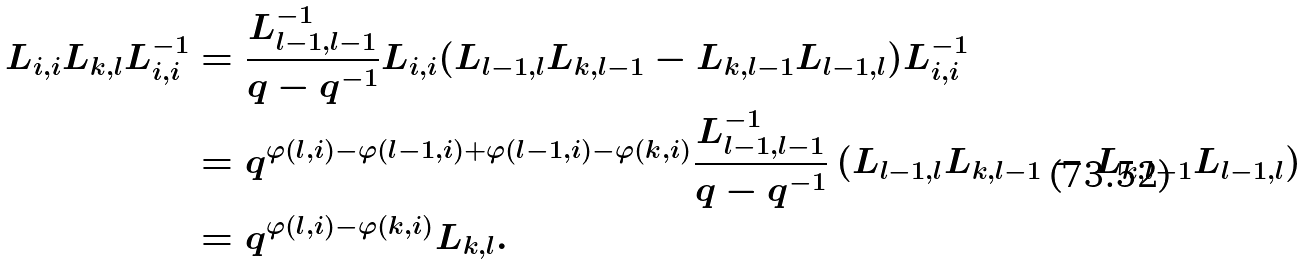<formula> <loc_0><loc_0><loc_500><loc_500>L _ { i , i } L _ { k , l } L _ { i , i } ^ { - 1 } & = \frac { L _ { l - 1 , l - 1 } ^ { - 1 } } { q - q ^ { - 1 } } L _ { i , i } ( L _ { l - 1 , l } L _ { k , l - 1 } - L _ { k , l - 1 } L _ { l - 1 , l } ) L _ { i , i } ^ { - 1 } \\ & = q ^ { \varphi ( l , i ) - \varphi ( l - 1 , i ) + \varphi ( l - 1 , i ) - \varphi ( k , i ) } \frac { L _ { l - 1 , l - 1 } ^ { - 1 } } { q - q ^ { - 1 } } \left ( L _ { l - 1 , l } L _ { k , l - 1 } - L _ { k , l - 1 } L _ { l - 1 , l } \right ) \\ & = q ^ { \varphi ( l , i ) - \varphi ( k , i ) } L _ { k , l } .</formula> 